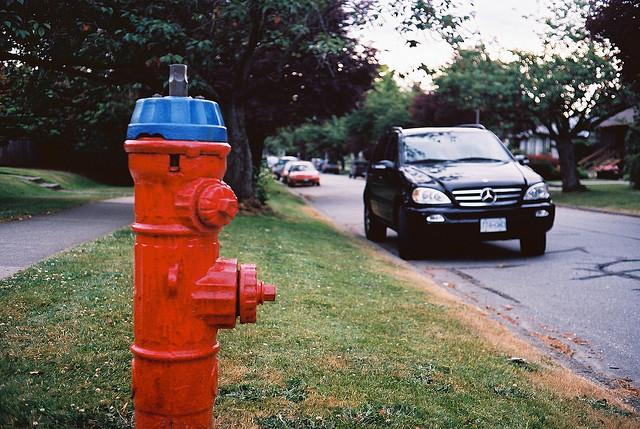Why is the black vehicle stopped near the curb? parked 